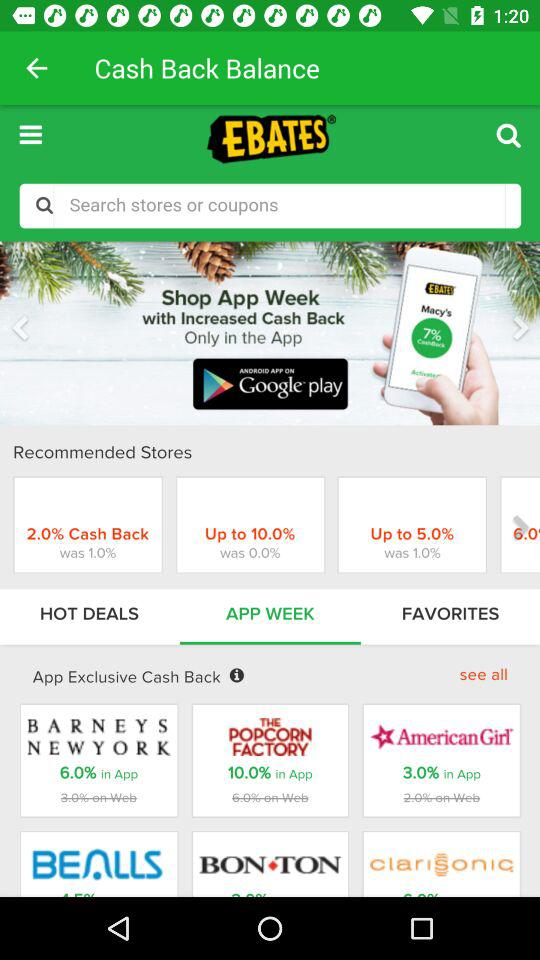How much more cash back do I get for shopping in the app than on the web for Barneys New York?
Answer the question using a single word or phrase. 3.0% 